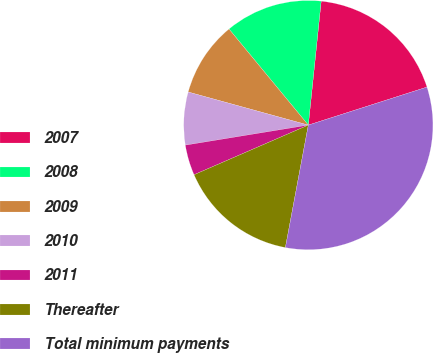Convert chart. <chart><loc_0><loc_0><loc_500><loc_500><pie_chart><fcel>2007<fcel>2008<fcel>2009<fcel>2010<fcel>2011<fcel>Thereafter<fcel>Total minimum payments<nl><fcel>18.42%<fcel>12.63%<fcel>9.74%<fcel>6.85%<fcel>3.95%<fcel>15.53%<fcel>32.88%<nl></chart> 